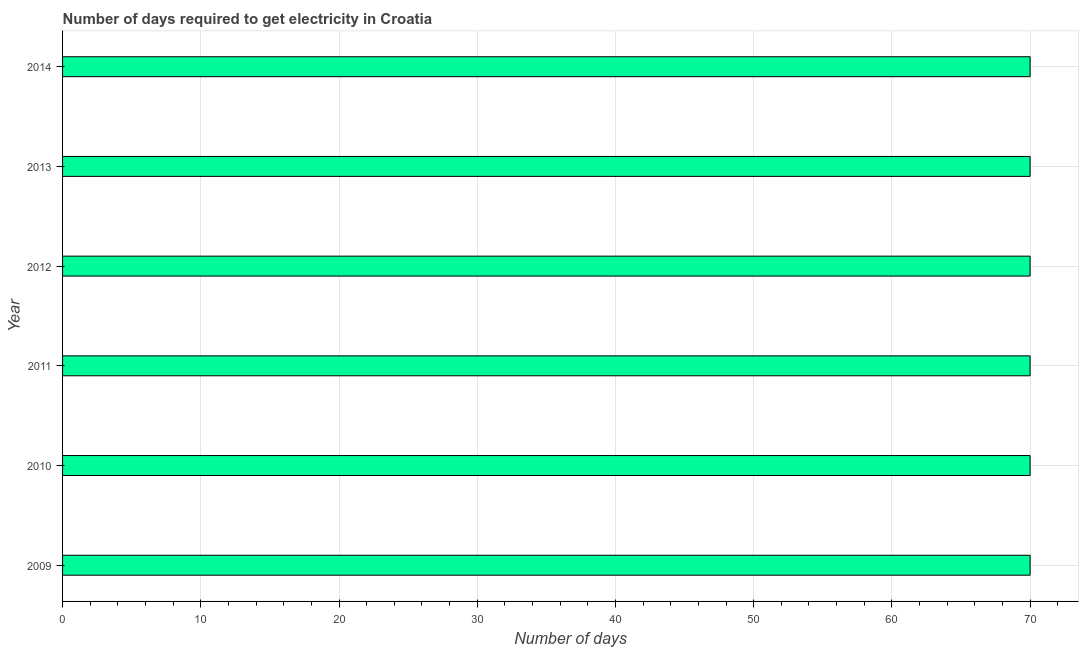Does the graph contain any zero values?
Provide a succinct answer. No. Does the graph contain grids?
Provide a short and direct response. Yes. What is the title of the graph?
Offer a terse response. Number of days required to get electricity in Croatia. What is the label or title of the X-axis?
Provide a succinct answer. Number of days. What is the label or title of the Y-axis?
Your answer should be compact. Year. Across all years, what is the minimum time to get electricity?
Your response must be concise. 70. In which year was the time to get electricity maximum?
Ensure brevity in your answer.  2009. What is the sum of the time to get electricity?
Give a very brief answer. 420. What is the difference between the time to get electricity in 2009 and 2013?
Offer a very short reply. 0. What is the median time to get electricity?
Keep it short and to the point. 70. In how many years, is the time to get electricity greater than 70 ?
Keep it short and to the point. 0. Is the time to get electricity in 2013 less than that in 2014?
Provide a succinct answer. No. What is the difference between the highest and the lowest time to get electricity?
Your answer should be compact. 0. How many bars are there?
Keep it short and to the point. 6. How many years are there in the graph?
Make the answer very short. 6. What is the difference between two consecutive major ticks on the X-axis?
Make the answer very short. 10. Are the values on the major ticks of X-axis written in scientific E-notation?
Make the answer very short. No. What is the Number of days in 2009?
Ensure brevity in your answer.  70. What is the Number of days in 2010?
Keep it short and to the point. 70. What is the Number of days of 2011?
Keep it short and to the point. 70. What is the Number of days of 2012?
Provide a short and direct response. 70. What is the Number of days of 2013?
Your answer should be compact. 70. What is the Number of days of 2014?
Provide a succinct answer. 70. What is the difference between the Number of days in 2009 and 2010?
Your answer should be compact. 0. What is the difference between the Number of days in 2009 and 2013?
Provide a succinct answer. 0. What is the difference between the Number of days in 2009 and 2014?
Ensure brevity in your answer.  0. What is the difference between the Number of days in 2010 and 2011?
Provide a succinct answer. 0. What is the difference between the Number of days in 2010 and 2012?
Keep it short and to the point. 0. What is the difference between the Number of days in 2010 and 2014?
Keep it short and to the point. 0. What is the difference between the Number of days in 2011 and 2012?
Your answer should be very brief. 0. What is the difference between the Number of days in 2011 and 2014?
Give a very brief answer. 0. What is the difference between the Number of days in 2012 and 2013?
Give a very brief answer. 0. What is the difference between the Number of days in 2013 and 2014?
Keep it short and to the point. 0. What is the ratio of the Number of days in 2009 to that in 2011?
Keep it short and to the point. 1. What is the ratio of the Number of days in 2009 to that in 2012?
Your response must be concise. 1. What is the ratio of the Number of days in 2009 to that in 2013?
Offer a very short reply. 1. What is the ratio of the Number of days in 2009 to that in 2014?
Provide a succinct answer. 1. What is the ratio of the Number of days in 2010 to that in 2012?
Offer a terse response. 1. What is the ratio of the Number of days in 2011 to that in 2012?
Offer a terse response. 1. What is the ratio of the Number of days in 2012 to that in 2013?
Your answer should be compact. 1. What is the ratio of the Number of days in 2012 to that in 2014?
Offer a terse response. 1. What is the ratio of the Number of days in 2013 to that in 2014?
Offer a very short reply. 1. 